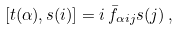Convert formula to latex. <formula><loc_0><loc_0><loc_500><loc_500>[ t ( \alpha ) , s ( i ) ] = i \, \bar { f } _ { \alpha i j } s ( j ) \, ,</formula> 